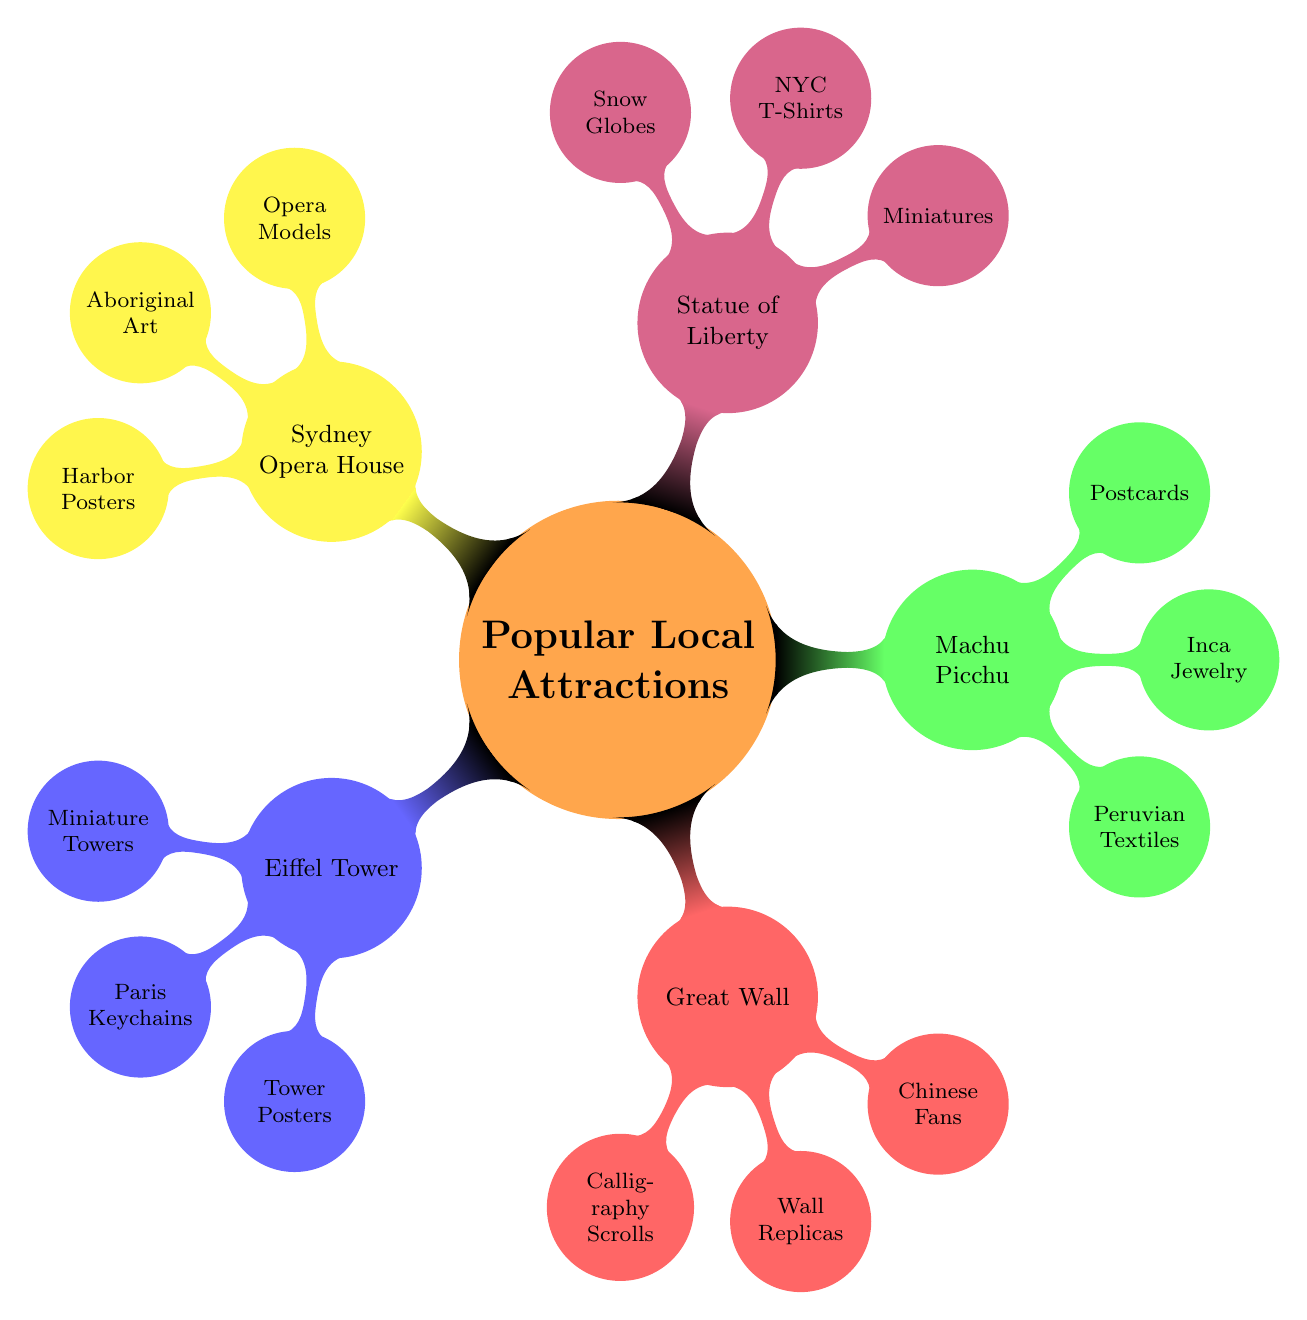What are the souvenir options associated with the Eiffel Tower? The diagram indicates the souvenir options connected to the Eiffel Tower, which are listed directly under it as Miniature Eiffel Towers, Paris-themed Keychains, and Eiffel Tower Posters.
Answer: Miniature Eiffel Towers, Paris-themed Keychains, Eiffel Tower Posters How many souvenir options does the Great Wall of China have? The Great Wall node contains three child nodes that represent its souvenir options: Chinese Calligraphy Scrolls, Great Wall Replicas, and Traditional Chinese Fans. Therefore, the total is three.
Answer: 3 Which local attraction has souvenirs themed around Aboriginal art? By inspecting the nodes in the diagram, the souvenir options connected to the Sydney Opera House specifically include Aboriginal Art Souvenirs.
Answer: Sydney Opera House What type of souvenirs are available for Machu Picchu? The diagram outlines that Machu Picchu has three specific types of souvenirs: Handwoven Peruvian Textiles, Inca-themed Jewelry, and Machu Picchu Postcards.
Answer: Handwoven Peruvian Textiles, Inca-themed Jewelry, Machu Picchu Postcards Which attraction is connected to snow globes as a souvenir option? On the diagram, the Statue of Liberty's node includes the souvenir option of Liberty-themed Snow Globes, indicating its connection to this type of souvenir.
Answer: Statue of Liberty 